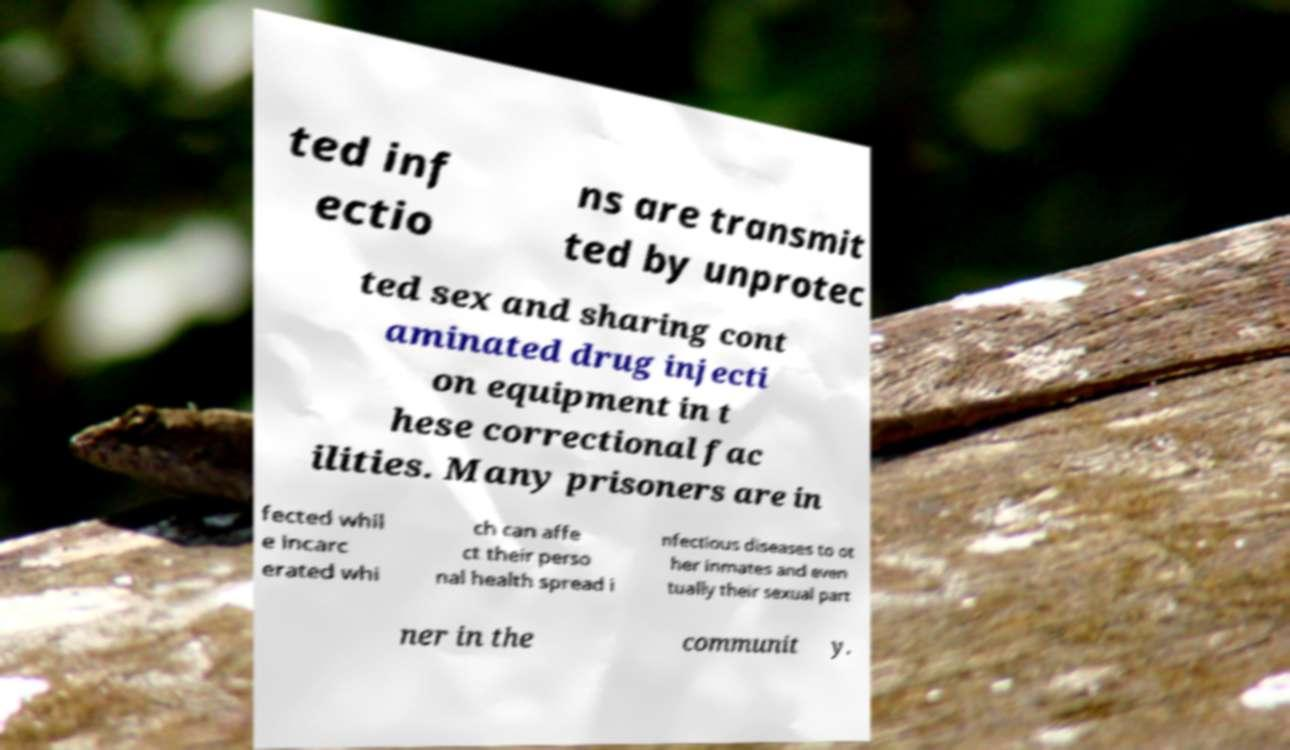Can you accurately transcribe the text from the provided image for me? ted inf ectio ns are transmit ted by unprotec ted sex and sharing cont aminated drug injecti on equipment in t hese correctional fac ilities. Many prisoners are in fected whil e incarc erated whi ch can affe ct their perso nal health spread i nfectious diseases to ot her inmates and even tually their sexual part ner in the communit y. 